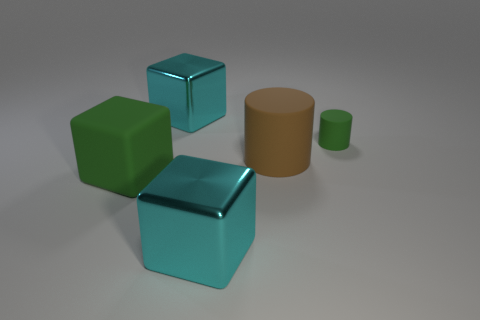There is a large matte object right of the large green cube; what is its shape?
Make the answer very short. Cylinder. There is a large object that is the same color as the small cylinder; what is its material?
Your response must be concise. Rubber. What number of other objects are the same material as the large green block?
Provide a succinct answer. 2. Do the large brown rubber object and the green rubber thing on the left side of the green cylinder have the same shape?
Keep it short and to the point. No. There is another green thing that is made of the same material as the small green thing; what shape is it?
Keep it short and to the point. Cube. Are there more rubber things that are on the left side of the brown rubber cylinder than tiny matte cylinders in front of the green matte cube?
Give a very brief answer. Yes. How many things are tiny green rubber cylinders or tiny red shiny cylinders?
Keep it short and to the point. 1. What number of other objects are there of the same color as the tiny cylinder?
Ensure brevity in your answer.  1. There is a green matte thing that is the same size as the brown cylinder; what is its shape?
Keep it short and to the point. Cube. What is the color of the cylinder to the right of the brown rubber object?
Your response must be concise. Green. 